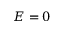Convert formula to latex. <formula><loc_0><loc_0><loc_500><loc_500>E = 0</formula> 